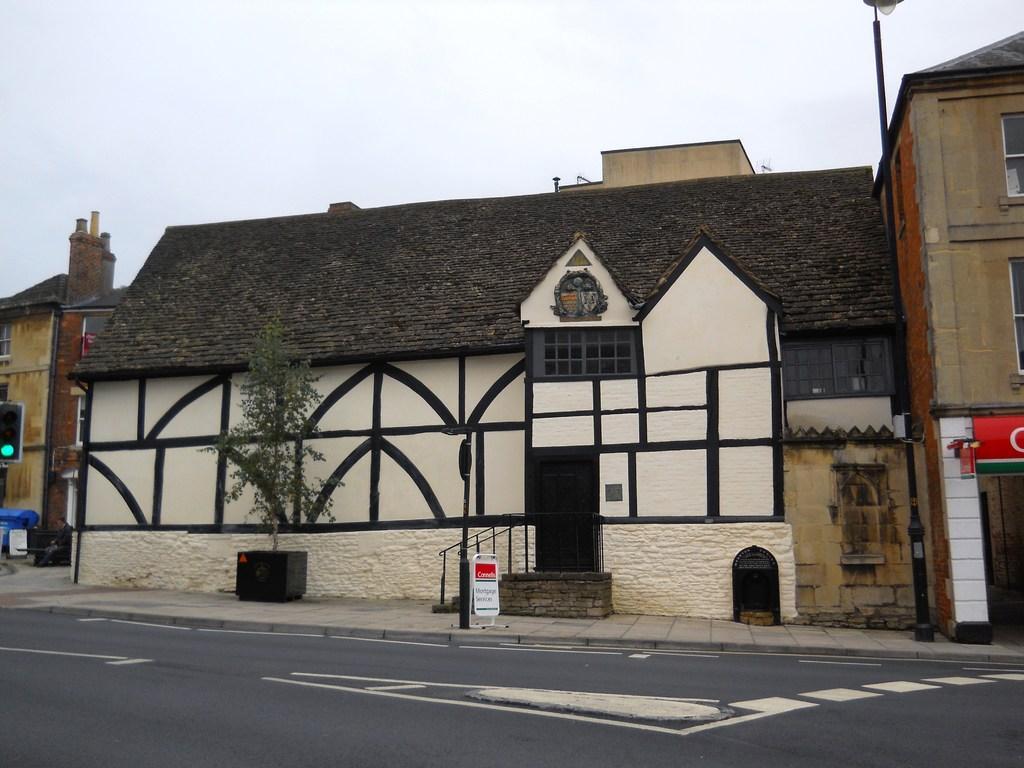How would you summarize this image in a sentence or two? In the image we can see a building and these are the windows of the building. This is a road and white lines on the road, plant pot, pole, board, stairs and a sky. 